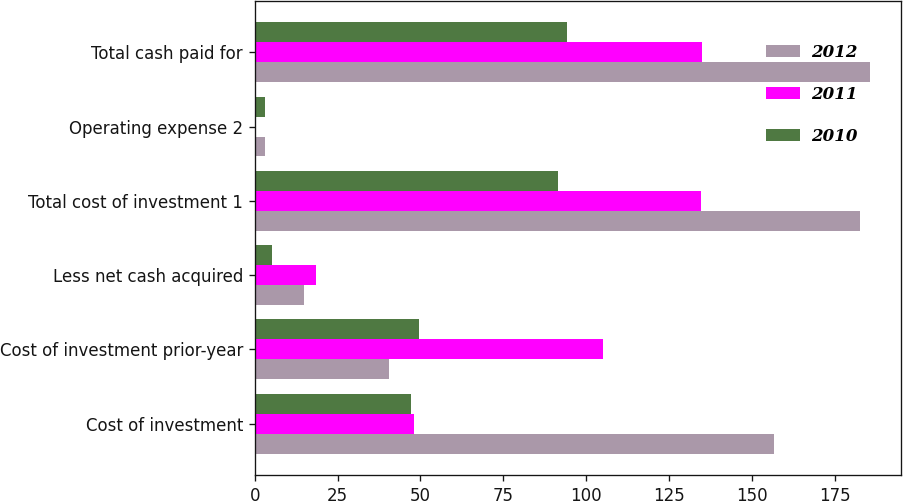Convert chart. <chart><loc_0><loc_0><loc_500><loc_500><stacked_bar_chart><ecel><fcel>Cost of investment<fcel>Cost of investment prior-year<fcel>Less net cash acquired<fcel>Total cost of investment 1<fcel>Operating expense 2<fcel>Total cash paid for<nl><fcel>2012<fcel>156.8<fcel>40.6<fcel>14.8<fcel>182.6<fcel>3.2<fcel>185.8<nl><fcel>2011<fcel>48<fcel>105.1<fcel>18.5<fcel>134.6<fcel>0.5<fcel>135.1<nl><fcel>2010<fcel>47.1<fcel>49.6<fcel>5.3<fcel>91.4<fcel>3<fcel>94.4<nl></chart> 